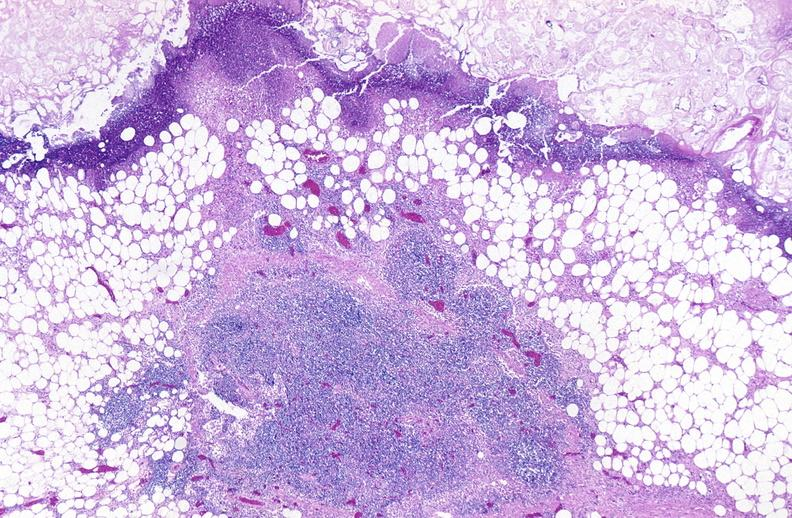does this image show pancreatic fat necrosis?
Answer the question using a single word or phrase. Yes 